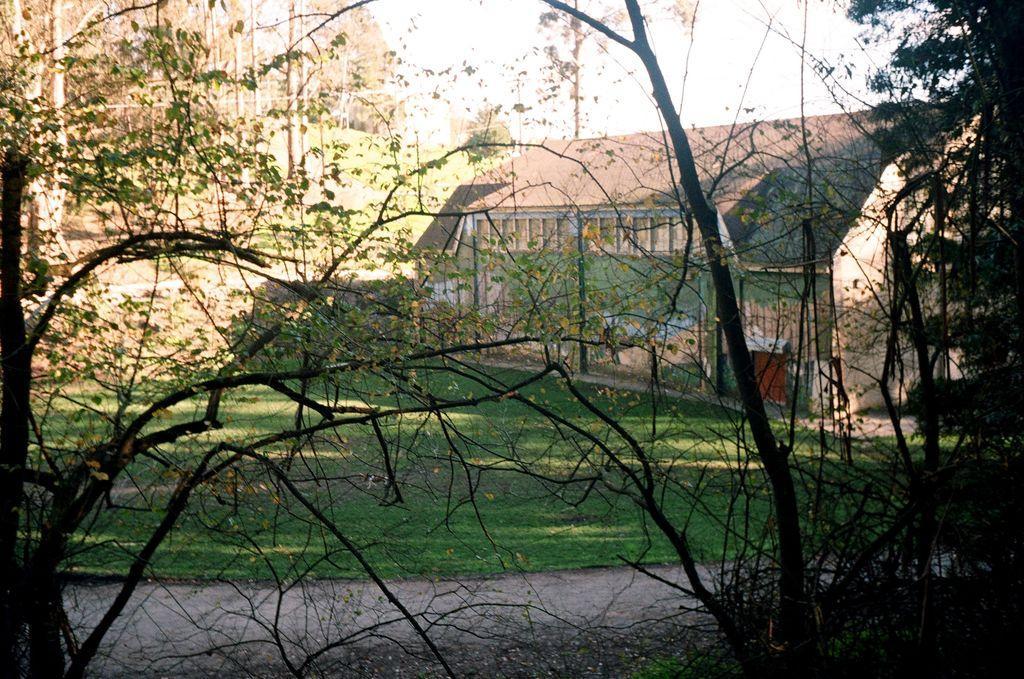Could you give a brief overview of what you see in this image? This picture is clicked outside. In the foreground we can see the plants and trees. In the center there is a green grass, house and some other objects. In the background there is a sky and buildings. 